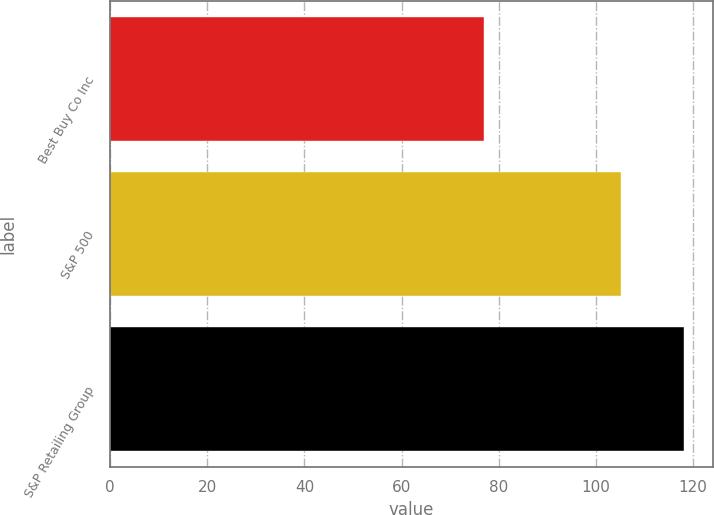<chart> <loc_0><loc_0><loc_500><loc_500><bar_chart><fcel>Best Buy Co Inc<fcel>S&P 500<fcel>S&P Retailing Group<nl><fcel>76.88<fcel>105.12<fcel>118.24<nl></chart> 